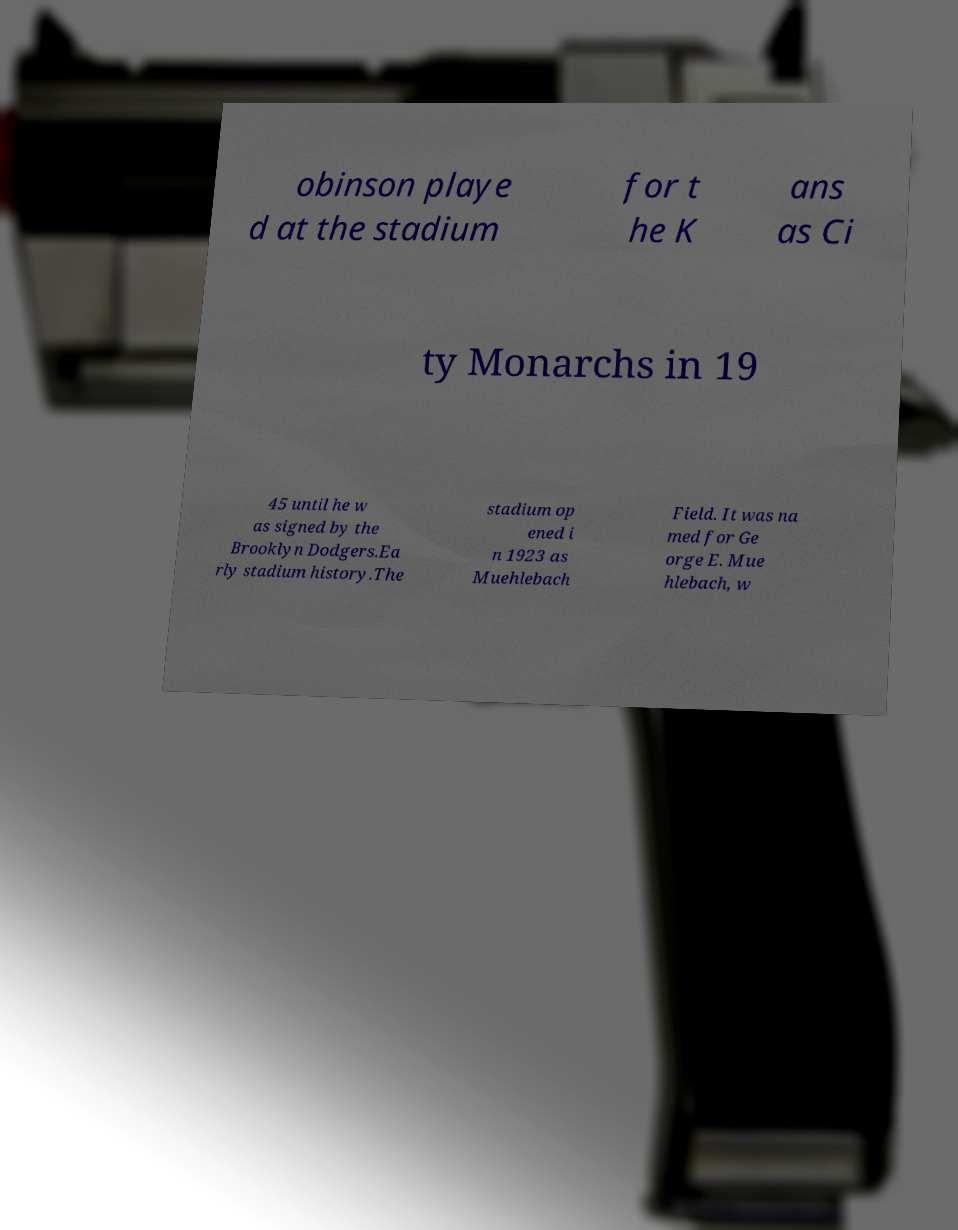For documentation purposes, I need the text within this image transcribed. Could you provide that? obinson playe d at the stadium for t he K ans as Ci ty Monarchs in 19 45 until he w as signed by the Brooklyn Dodgers.Ea rly stadium history.The stadium op ened i n 1923 as Muehlebach Field. It was na med for Ge orge E. Mue hlebach, w 